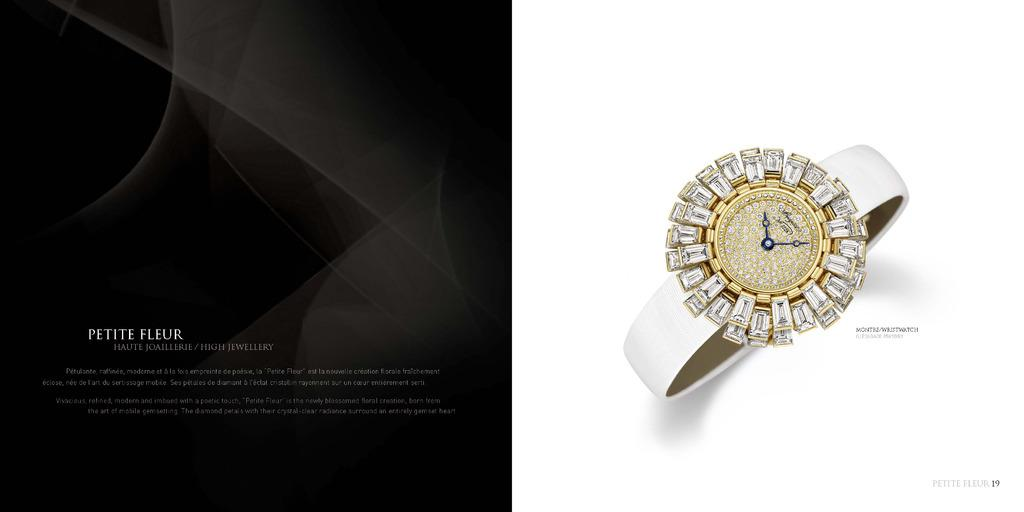<image>
Offer a succinct explanation of the picture presented. A Petite Fluer silver banded ring with a diamond face clock on it. 